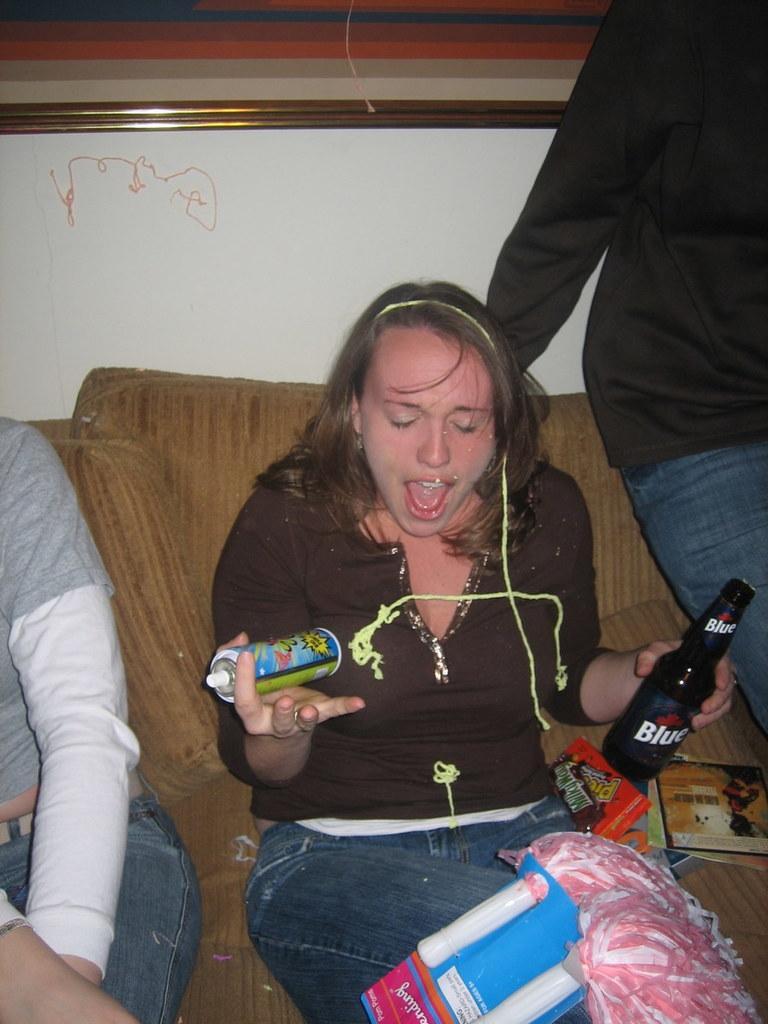In one or two sentences, can you explain what this image depicts? in this image, we can see 3 peoples are sat on the couch. and the center of the image, there is a woman holding spray bottle on his right hand. and his left hand, she holding some bottle. on her lap,we can saw some ribbon type material. behind her we can saw some chocolates. and here we can see cream color wall and a photo frame here. 